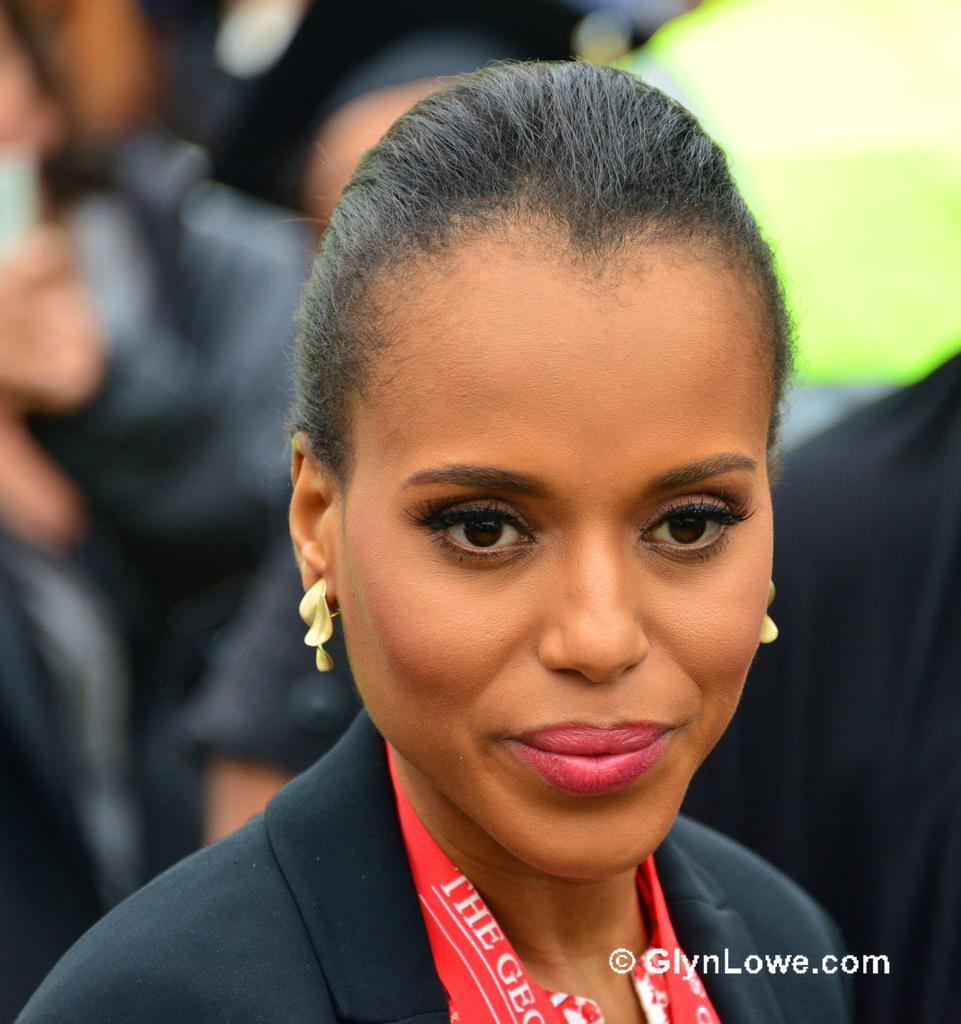Who is the main subject in the image? There is a woman in the image. What is the woman wearing in the image? The woman is wearing a blazer. What type of accessory can be seen on the woman in the image? The woman has gold earrings. How is the background of the woman depicted in the image? The background of the woman is blurred. What type of grain is being transported by the woman in the image? There is no grain or transportation depicted in the image; it features a woman wearing a blazer and gold earrings with a blurred background. 